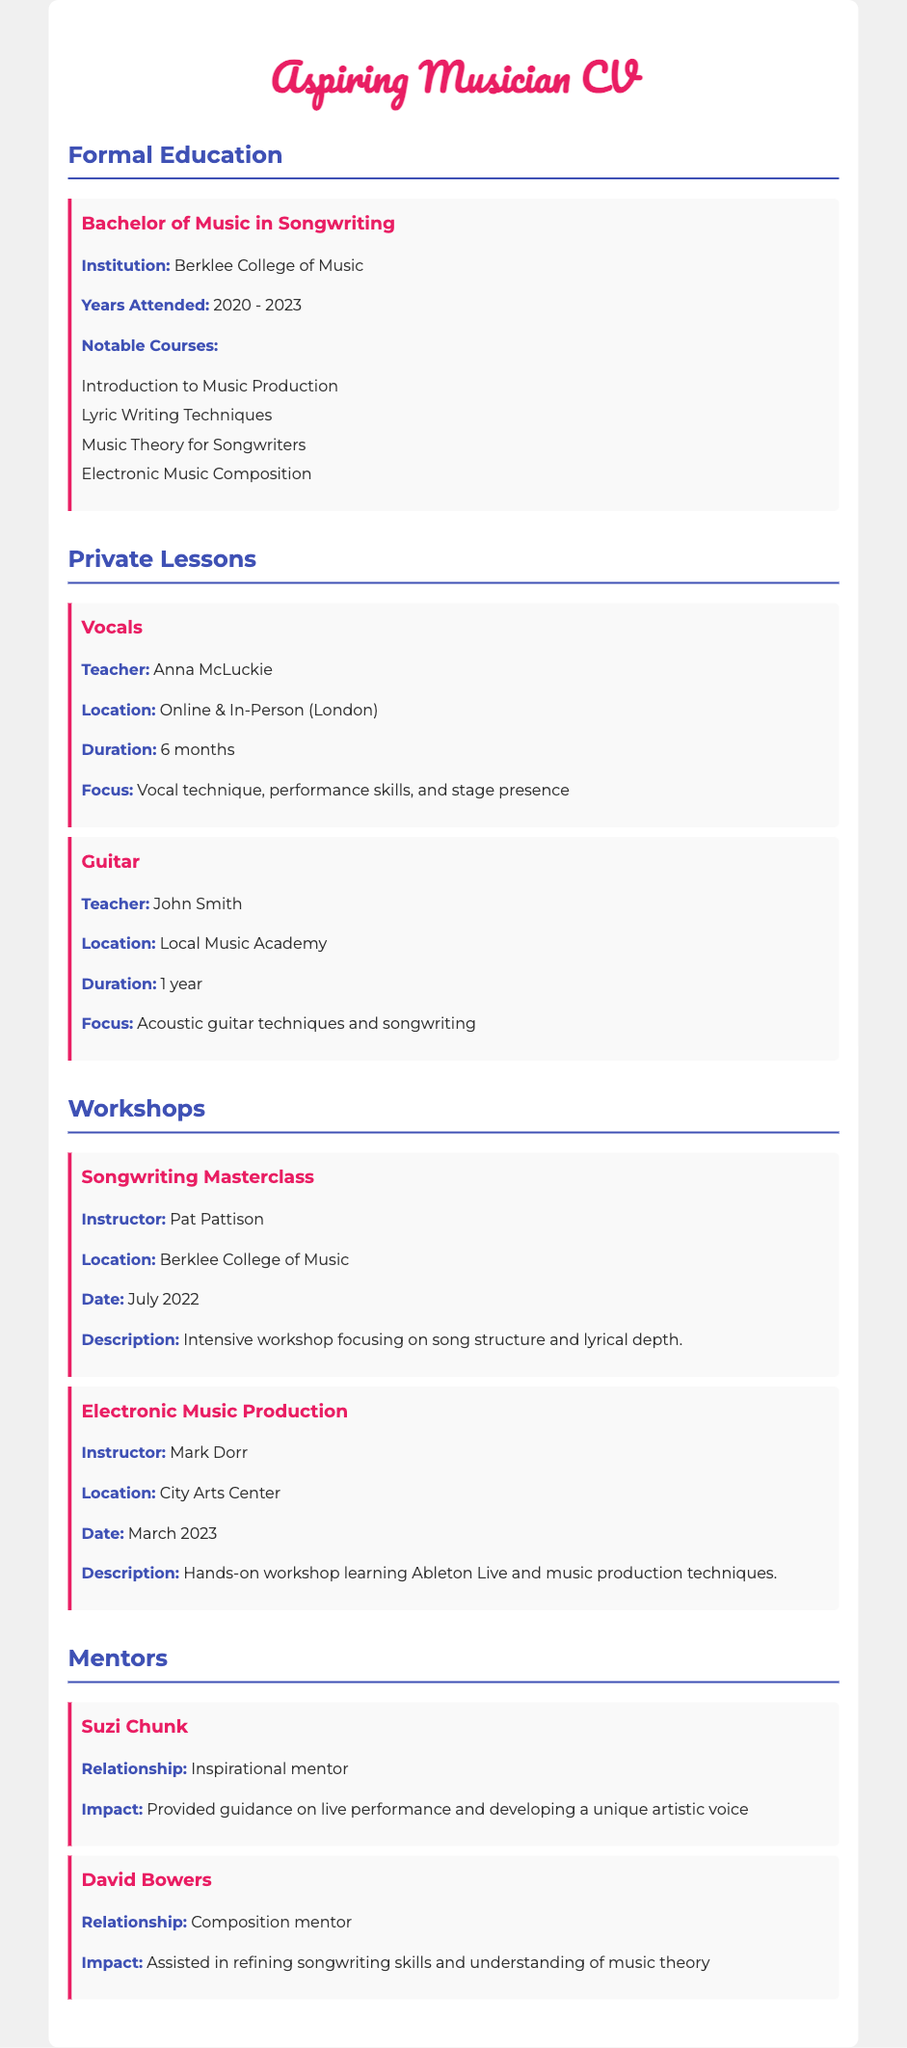what degree was obtained? The document states the degree earned in formal education, which is a Bachelor's degree in Songwriting.
Answer: Bachelor of Music in Songwriting who is the instructor for the Songwriting Masterclass? The document lists Pat Pattison as the instructor for the Songwriting Masterclass workshop.
Answer: Pat Pattison how long did the guitar lessons last? The document specifies the duration of guitar lessons taken.
Answer: 1 year which institution did the formal education take place? The document indicates that the degree was obtained from Berklee College of Music.
Answer: Berklee College of Music what was a focus of the vocals private lessons? The document describes the areas of focus for the vocal lessons taken.
Answer: Vocal technique, performance skills, and stage presence who is mentioned as an inspirational mentor? The document identifies Suzi Chunk as an inspirational mentor.
Answer: Suzi Chunk what technique was learned in the Electronic Music Production workshop? The document mentions that music production techniques were part of the workshop's content.
Answer: Music production techniques in what year did the Songwriting Masterclass take place? The document provides the date for the Songwriting Masterclass workshop.
Answer: July 2022 how many notable courses were listed under formal education? The document states the number of notable courses included in the formal education section.
Answer: 4 